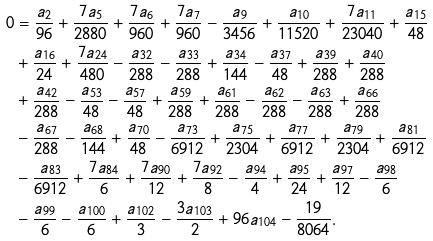Convert formula to latex. <formula><loc_0><loc_0><loc_500><loc_500>0 & = \frac { a _ { 2 } } { 9 6 } + \frac { 7 a _ { 5 } } { 2 8 8 0 } + \frac { 7 a _ { 6 } } { 9 6 0 } + \frac { 7 a _ { 7 } } { 9 6 0 } - \frac { a _ { 9 } } { 3 4 5 6 } + \frac { a _ { 1 0 } } { 1 1 5 2 0 } + \frac { 7 a _ { 1 1 } } { 2 3 0 4 0 } + \frac { a _ { 1 5 } } { 4 8 } \\ & + \frac { a _ { 1 6 } } { 2 4 } + \frac { 7 a _ { 2 4 } } { 4 8 0 } - \frac { a _ { 3 2 } } { 2 8 8 } - \frac { a _ { 3 3 } } { 2 8 8 } + \frac { a _ { 3 4 } } { 1 4 4 } - \frac { a _ { 3 7 } } { 4 8 } + \frac { a _ { 3 9 } } { 2 8 8 } + \frac { a _ { 4 0 } } { 2 8 8 } \\ & + \frac { a _ { 4 2 } } { 2 8 8 } - \frac { a _ { 5 3 } } { 4 8 } - \frac { a _ { 5 7 } } { 4 8 } + \frac { a _ { 5 9 } } { 2 8 8 } + \frac { a _ { 6 1 } } { 2 8 8 } - \frac { a _ { 6 2 } } { 2 8 8 } - \frac { a _ { 6 3 } } { 2 8 8 } + \frac { a _ { 6 6 } } { 2 8 8 } \\ & - \frac { a _ { 6 7 } } { 2 8 8 } - \frac { a _ { 6 8 } } { 1 4 4 } + \frac { a _ { 7 0 } } { 4 8 } - \frac { a _ { 7 3 } } { 6 9 1 2 } + \frac { a _ { 7 5 } } { 2 3 0 4 } + \frac { a _ { 7 7 } } { 6 9 1 2 } + \frac { a _ { 7 9 } } { 2 3 0 4 } + \frac { a _ { 8 1 } } { 6 9 1 2 } \\ & - \frac { a _ { 8 3 } } { 6 9 1 2 } + \frac { 7 a _ { 8 4 } } { 6 } + \frac { 7 a _ { 9 0 } } { 1 2 } + \frac { 7 a _ { 9 2 } } { 8 } - \frac { a _ { 9 4 } } { 4 } + \frac { a _ { 9 5 } } { 2 4 } + \frac { a _ { 9 7 } } { 1 2 } - \frac { a _ { 9 8 } } { 6 } \\ & - \frac { a _ { 9 9 } } { 6 } - \frac { a _ { 1 0 0 } } { 6 } + \frac { a _ { 1 0 2 } } { 3 } - \frac { 3 a _ { 1 0 3 } } { 2 } + 9 6 a _ { 1 0 4 } - \frac { 1 9 } { 8 0 6 4 } .</formula> 